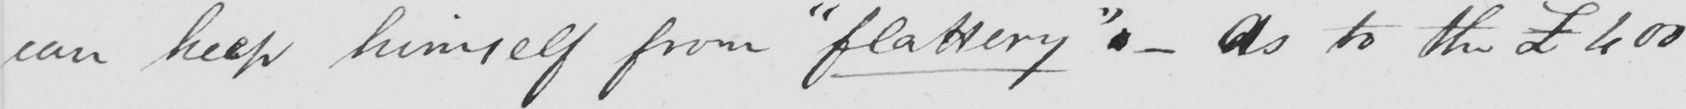Please transcribe the handwritten text in this image. can keep himself from  " flattery "  .  _  As to the £400 